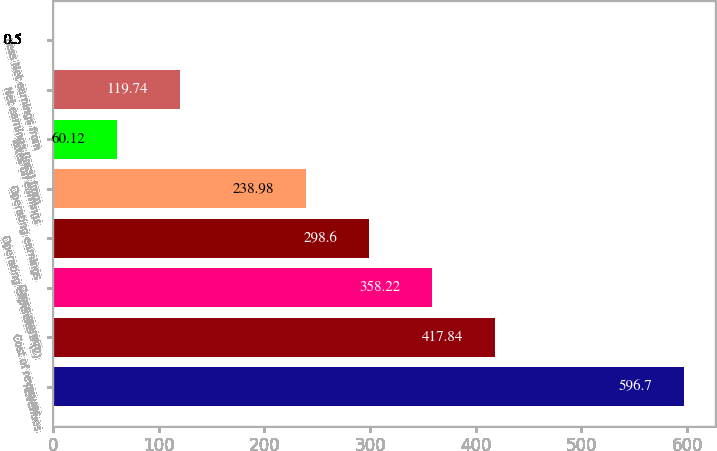<chart> <loc_0><loc_0><loc_500><loc_500><bar_chart><fcel>Revenues<fcel>Cost of revenues<fcel>Gross margin<fcel>Operating expenses ^(2)<fcel>Operating earnings<fcel>Taxes on earnings<fcel>Net earnings (loss) from<fcel>Less Net earnings from<nl><fcel>596.7<fcel>417.84<fcel>358.22<fcel>298.6<fcel>238.98<fcel>60.12<fcel>119.74<fcel>0.5<nl></chart> 